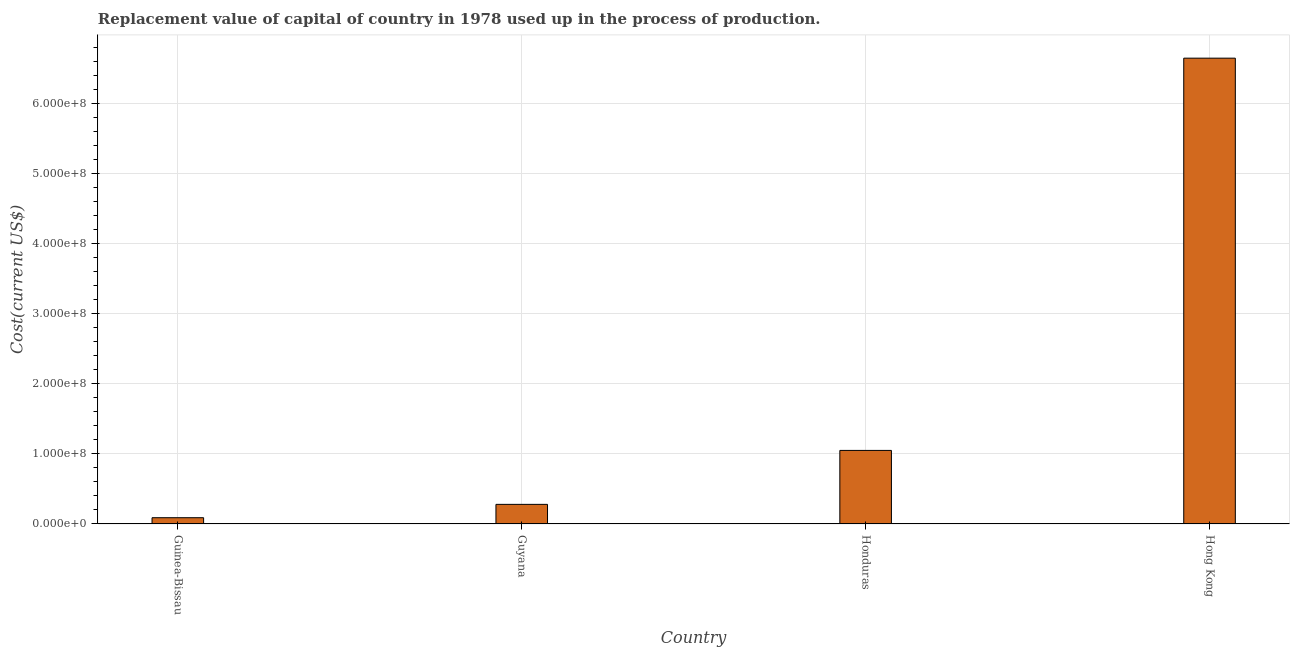Does the graph contain any zero values?
Your response must be concise. No. Does the graph contain grids?
Offer a terse response. Yes. What is the title of the graph?
Your response must be concise. Replacement value of capital of country in 1978 used up in the process of production. What is the label or title of the X-axis?
Ensure brevity in your answer.  Country. What is the label or title of the Y-axis?
Offer a terse response. Cost(current US$). What is the consumption of fixed capital in Guyana?
Provide a short and direct response. 2.80e+07. Across all countries, what is the maximum consumption of fixed capital?
Make the answer very short. 6.65e+08. Across all countries, what is the minimum consumption of fixed capital?
Your response must be concise. 8.96e+06. In which country was the consumption of fixed capital maximum?
Offer a terse response. Hong Kong. In which country was the consumption of fixed capital minimum?
Keep it short and to the point. Guinea-Bissau. What is the sum of the consumption of fixed capital?
Provide a succinct answer. 8.07e+08. What is the difference between the consumption of fixed capital in Honduras and Hong Kong?
Give a very brief answer. -5.60e+08. What is the average consumption of fixed capital per country?
Make the answer very short. 2.02e+08. What is the median consumption of fixed capital?
Provide a succinct answer. 6.65e+07. What is the ratio of the consumption of fixed capital in Guinea-Bissau to that in Hong Kong?
Your response must be concise. 0.01. Is the consumption of fixed capital in Guyana less than that in Honduras?
Your answer should be compact. Yes. What is the difference between the highest and the second highest consumption of fixed capital?
Give a very brief answer. 5.60e+08. What is the difference between the highest and the lowest consumption of fixed capital?
Provide a short and direct response. 6.56e+08. How many countries are there in the graph?
Keep it short and to the point. 4. What is the difference between two consecutive major ticks on the Y-axis?
Your response must be concise. 1.00e+08. What is the Cost(current US$) in Guinea-Bissau?
Provide a succinct answer. 8.96e+06. What is the Cost(current US$) of Guyana?
Keep it short and to the point. 2.80e+07. What is the Cost(current US$) in Honduras?
Keep it short and to the point. 1.05e+08. What is the Cost(current US$) in Hong Kong?
Provide a short and direct response. 6.65e+08. What is the difference between the Cost(current US$) in Guinea-Bissau and Guyana?
Provide a succinct answer. -1.90e+07. What is the difference between the Cost(current US$) in Guinea-Bissau and Honduras?
Give a very brief answer. -9.61e+07. What is the difference between the Cost(current US$) in Guinea-Bissau and Hong Kong?
Provide a short and direct response. -6.56e+08. What is the difference between the Cost(current US$) in Guyana and Honduras?
Ensure brevity in your answer.  -7.70e+07. What is the difference between the Cost(current US$) in Guyana and Hong Kong?
Offer a terse response. -6.37e+08. What is the difference between the Cost(current US$) in Honduras and Hong Kong?
Offer a very short reply. -5.60e+08. What is the ratio of the Cost(current US$) in Guinea-Bissau to that in Guyana?
Offer a terse response. 0.32. What is the ratio of the Cost(current US$) in Guinea-Bissau to that in Honduras?
Your answer should be very brief. 0.09. What is the ratio of the Cost(current US$) in Guinea-Bissau to that in Hong Kong?
Provide a short and direct response. 0.01. What is the ratio of the Cost(current US$) in Guyana to that in Honduras?
Give a very brief answer. 0.27. What is the ratio of the Cost(current US$) in Guyana to that in Hong Kong?
Keep it short and to the point. 0.04. What is the ratio of the Cost(current US$) in Honduras to that in Hong Kong?
Give a very brief answer. 0.16. 